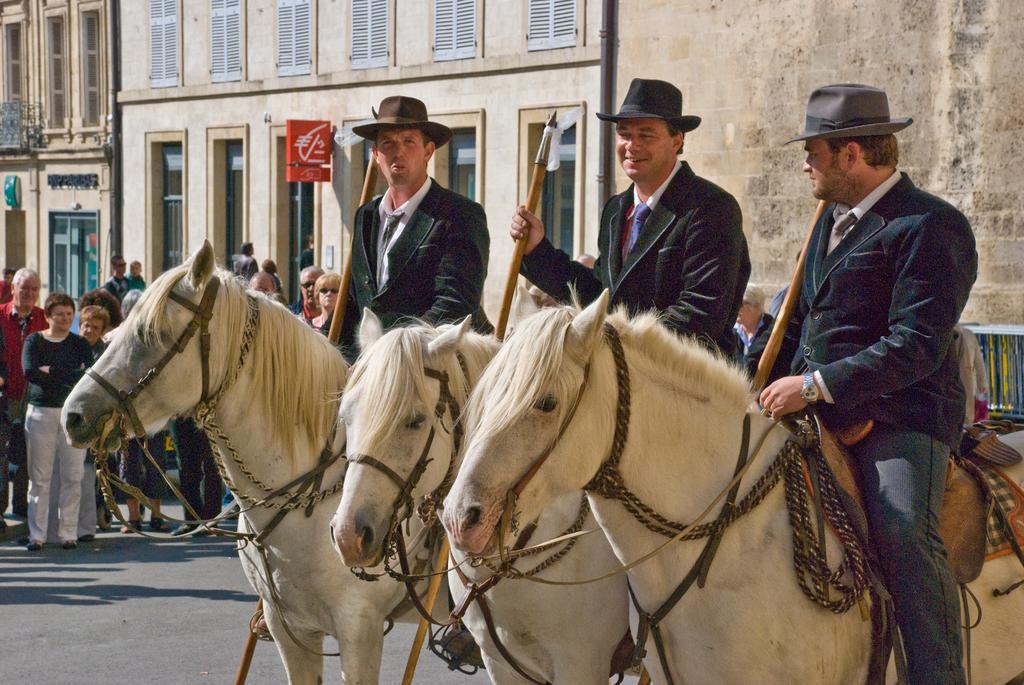How would you summarize this image in a sentence or two? In this image I can see three men are sitting on horses. I can also see all of them are holding sticks. In the background I can see few more people and number of buildings. 